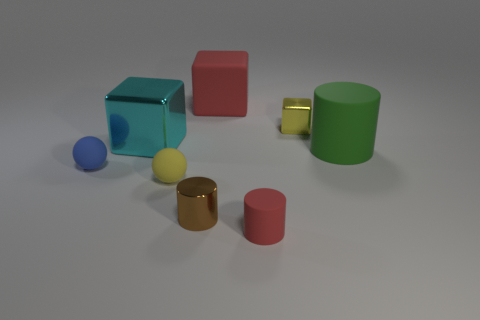There is a yellow object on the left side of the red object that is in front of the big green rubber cylinder; what number of large cylinders are to the left of it?
Make the answer very short. 0. There is a green matte thing; is it the same shape as the red matte object in front of the tiny yellow matte ball?
Your response must be concise. Yes. Is the number of small yellow matte cylinders greater than the number of yellow metallic objects?
Keep it short and to the point. No. Does the matte thing left of the large cyan block have the same shape as the yellow rubber thing?
Your answer should be very brief. Yes. Are there more large green objects that are in front of the large green rubber cylinder than blue things?
Your response must be concise. No. There is a large thing behind the block that is to the right of the big red cube; what color is it?
Provide a succinct answer. Red. How many big yellow rubber cylinders are there?
Your answer should be very brief. 0. What number of rubber things are behind the small blue matte thing and in front of the small blue matte ball?
Offer a terse response. 0. There is a small metallic cube; is it the same color as the ball on the right side of the blue matte object?
Keep it short and to the point. Yes. The large rubber object that is left of the green cylinder has what shape?
Keep it short and to the point. Cube. 